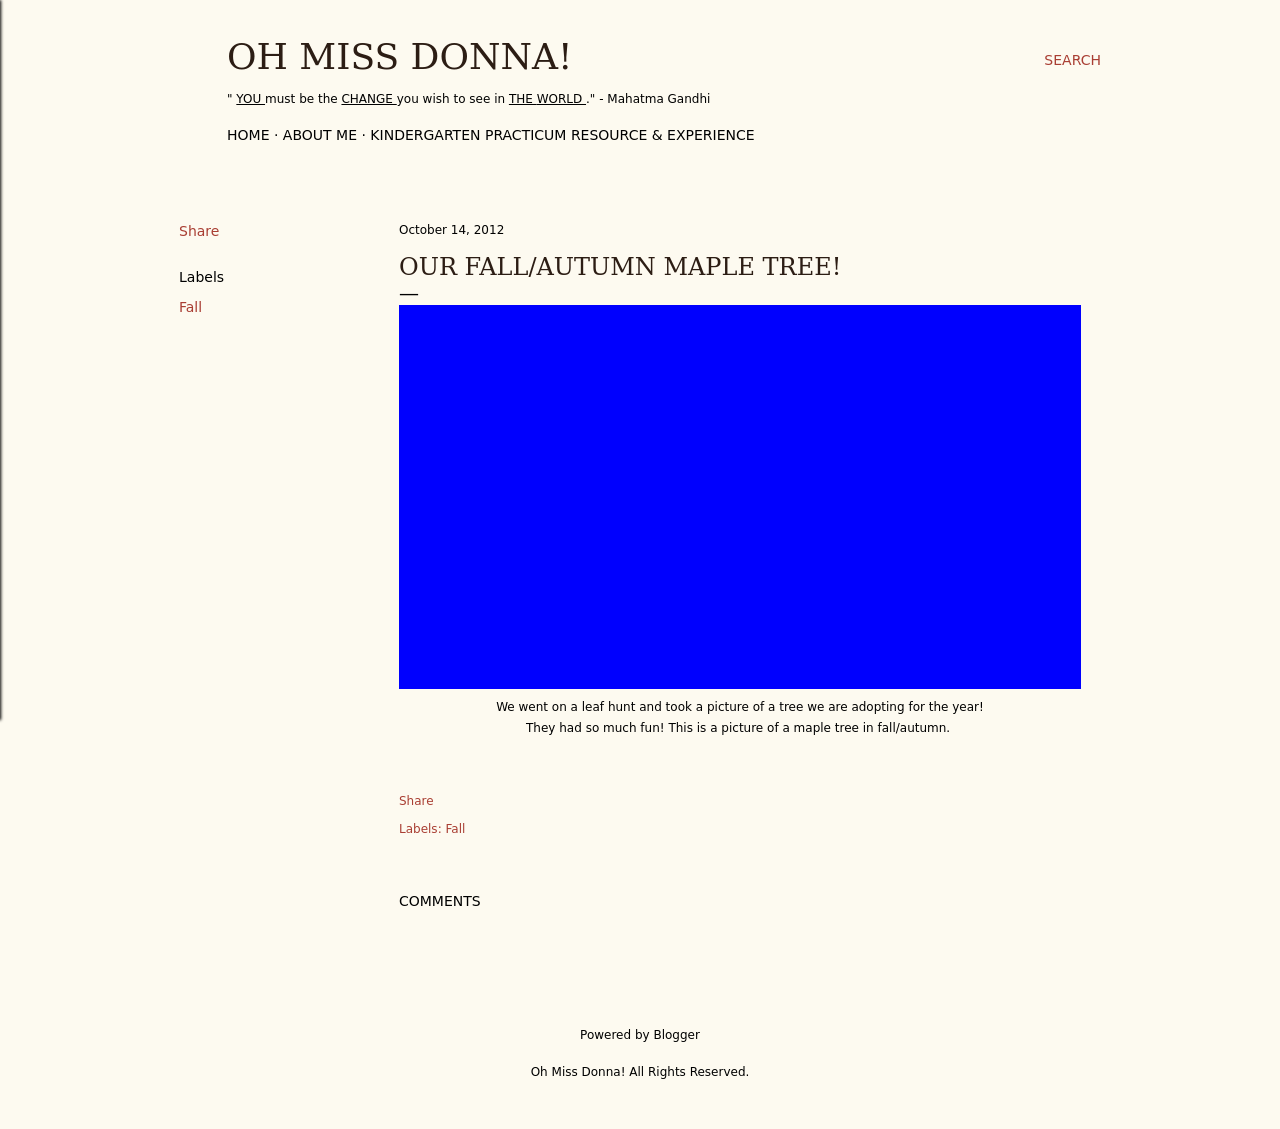How can the theme of fall be visually represented in an educational setting? Visually representing fall in an educational setting can be both fun and informative. Decorations might include leaves, acorns, and branches collected during nature walks. Art projects, like leaf rubbings or creating collages from fall foliage, also reflect the season. Bulletin boards could display information about the changing seasons, and visuals such as charts or diagrams showing why leaves change color. Additionally, incorporating seasonal colors like orange, yellow, and red into classroom materials and decor can enhance the autumnal theme. 